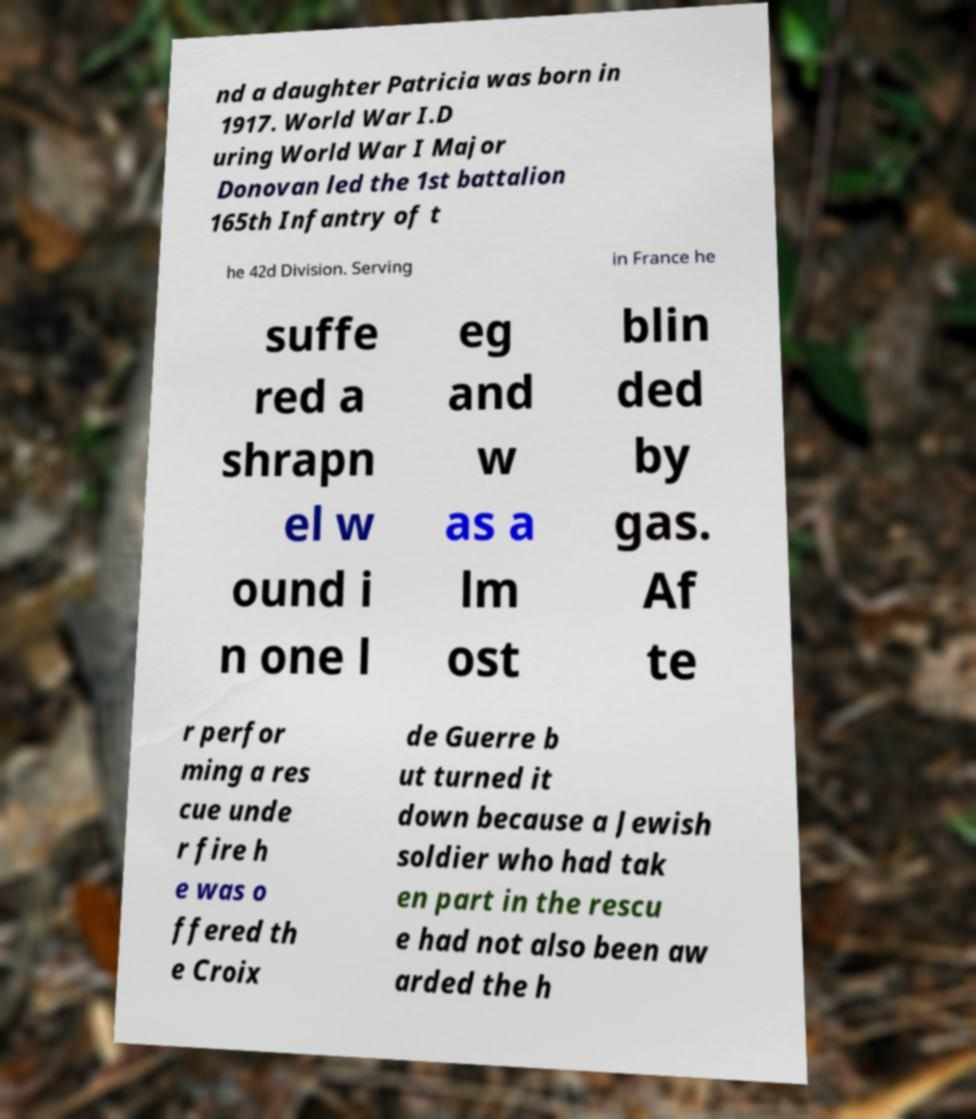Please identify and transcribe the text found in this image. nd a daughter Patricia was born in 1917. World War I.D uring World War I Major Donovan led the 1st battalion 165th Infantry of t he 42d Division. Serving in France he suffe red a shrapn el w ound i n one l eg and w as a lm ost blin ded by gas. Af te r perfor ming a res cue unde r fire h e was o ffered th e Croix de Guerre b ut turned it down because a Jewish soldier who had tak en part in the rescu e had not also been aw arded the h 